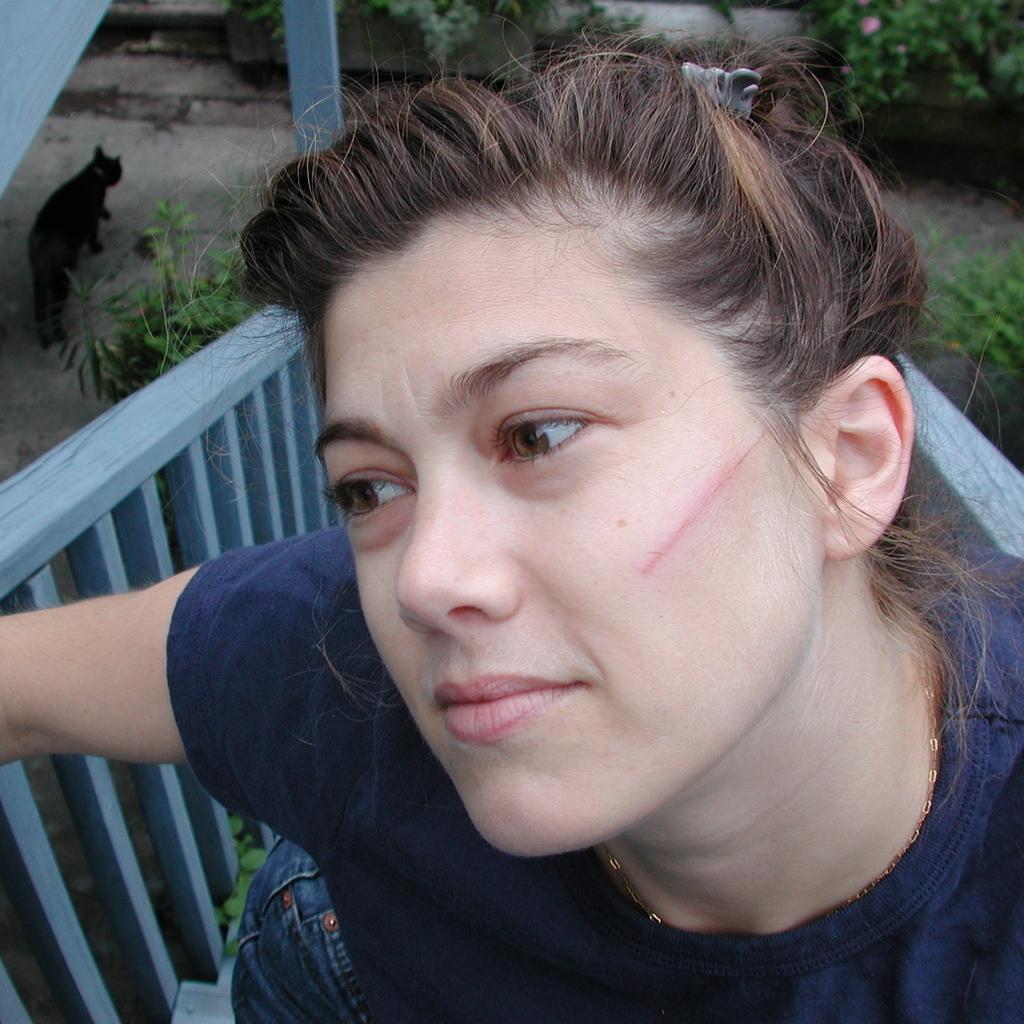Please provide a concise description of this image. In this picture I can see a woman in front and I see a red color line on her cheek. In the background I see the railings, a black color cat and few plants. 